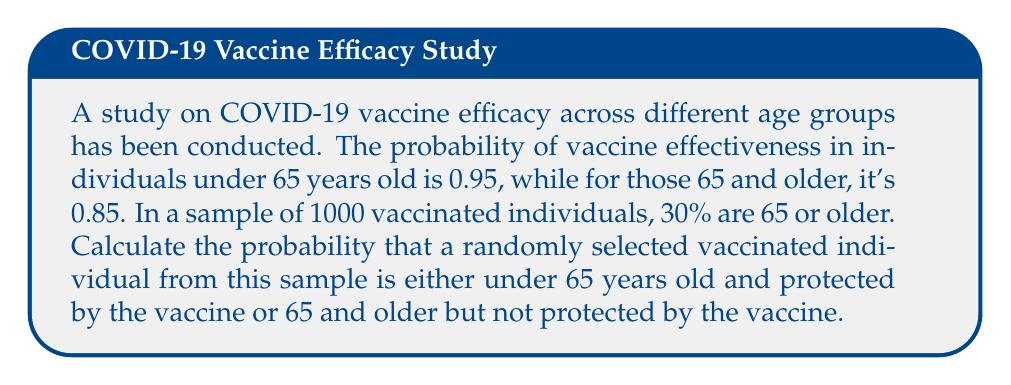Could you help me with this problem? Let's approach this step-by-step using the law of total probability:

1) Define events:
   A: Individual is under 65
   B: Individual is 65 or older
   P: Individual is protected by the vaccine

2) Given probabilities:
   $P(A) = 0.70$ (70% under 65)
   $P(B) = 0.30$ (30% 65 or older)
   $P(P|A) = 0.95$ (95% effectiveness for under 65)
   $P(P|B) = 0.85$ (85% effectiveness for 65 and older)

3) We need to calculate:
   $P(\text{under 65 and protected}) + P(\text{65 or older and not protected})$

4) This can be written as:
   $P(A \cap P) + P(B \cap P^c)$

5) Using the multiplication rule:
   $P(A \cap P) = P(A) \cdot P(P|A) = 0.70 \cdot 0.95 = 0.665$

6) For the second part:
   $P(B \cap P^c) = P(B) \cdot P(P^c|B) = P(B) \cdot (1 - P(P|B))$
   $= 0.30 \cdot (1 - 0.85) = 0.30 \cdot 0.15 = 0.045$

7) Sum the probabilities:
   $P(A \cap P) + P(B \cap P^c) = 0.665 + 0.045 = 0.71$

Therefore, the probability is 0.71 or 71%.
Answer: 0.71 